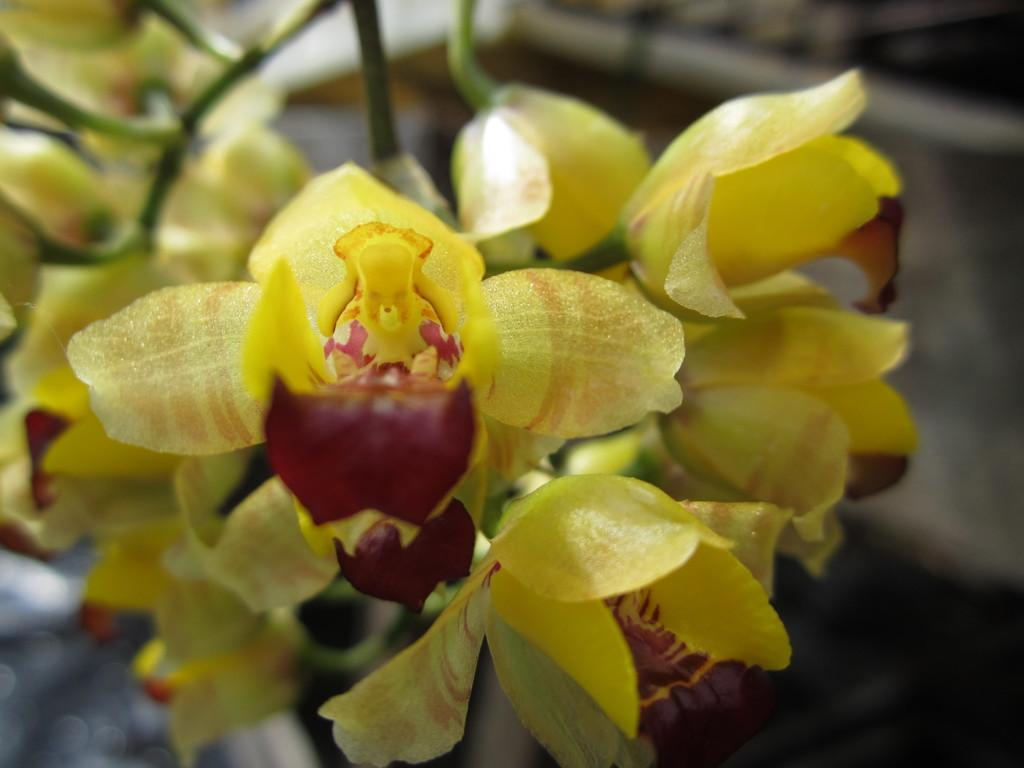What is the main subject of the image? There is a plant in the image. What color are the flowers on the plant? The plant has yellow flowers. Can you describe the background of the image? The background of the image is blurred. How does the plant use its chin to communicate with the flowers? Plants do not have chins, so they cannot use them to communicate with flowers. 